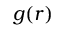<formula> <loc_0><loc_0><loc_500><loc_500>g ( r )</formula> 